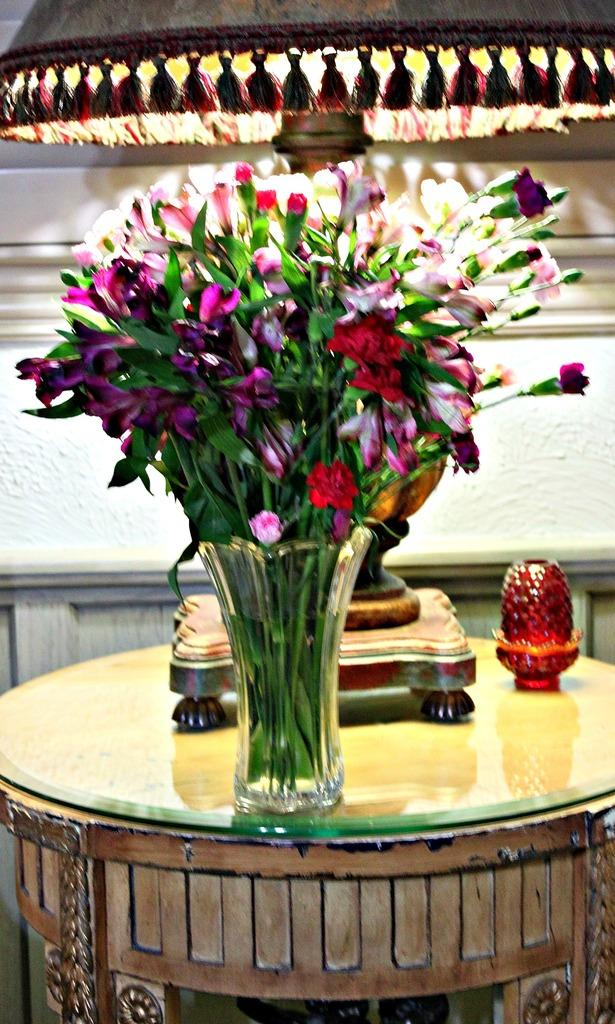What can be seen in the image that is used for holding flowers? There is a flower vase in the image. What type of surface are the objects placed on in the image? The objects are placed on a table in the image. What is the opinion of the flower vase about the current month? The flower vase does not have an opinion, as it is an inanimate object and cannot express thoughts or feelings. 